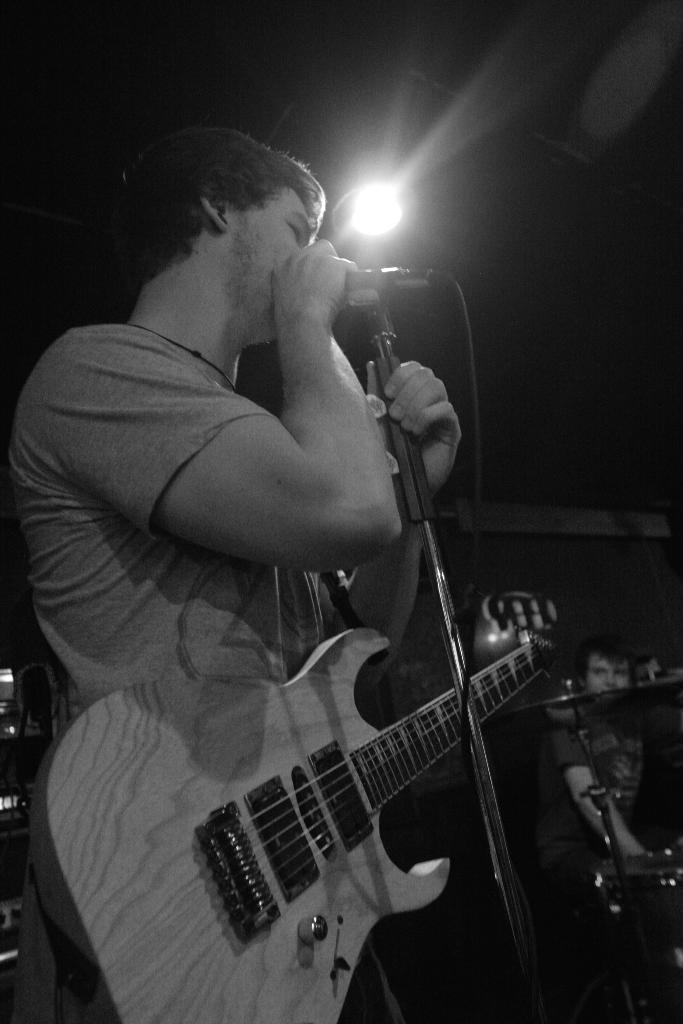Who is the main subject in the image? There is a man in the image. What is the man holding in the image? The man is holding a guitar. What is the man doing with the help of the microphone? The man is singing with the help of a microphone. What can be seen in the background of the image? There is a light visible in the background of the image. What type of bun is the man eating while playing the guitar in the image? There is no bun present in the image; the man is holding a guitar and singing with the help of a microphone. 